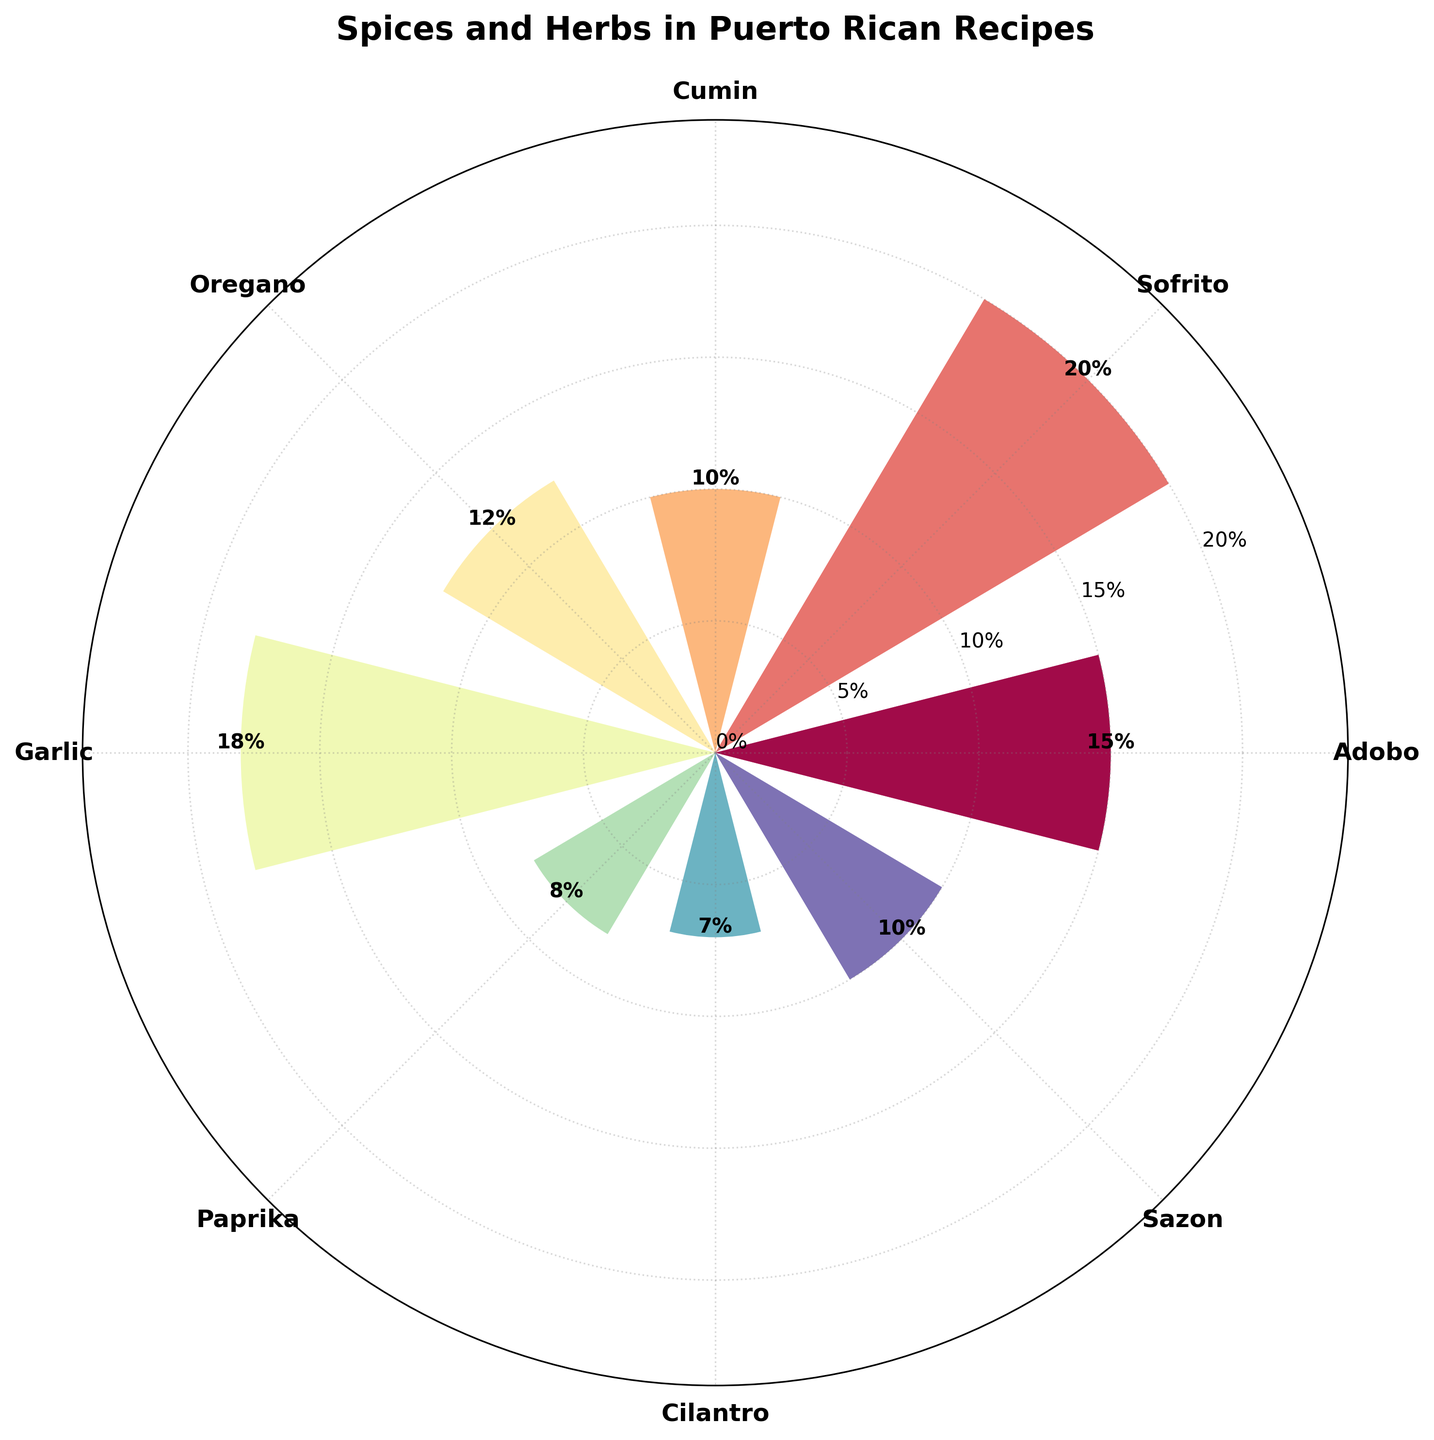What's the title of the figure? The title is typically located at the top of the figure. It describes the main topic or purpose of the chart.
Answer: Spices and Herbs in Puerto Rican Recipes Which spice/herb has the highest percentage of usage? By examining the heights of the bars, the tallest bar represents the spice/herb with the highest percentage.
Answer: Sofrito How many spices/herbs are shown in the chart? Count the number of different labeled bars or segments depicted around the polar axis.
Answer: 8 What is the combined usage percentage of Adobo and Sazon? Sum the percentage values associated with Adobo and Sazon from the chart. Adobo is 15%, and Sazon is 10%. Therefore, add 15% + 10%.
Answer: 25% Which spice/herb is used less, Cumin or Paprika? Compare the two heights of the bars corresponding to Cumin and Paprika. The shorter bar indicates the lesser-used herb.
Answer: Paprika What is the percentage difference between Garlic and Cilantro usage? Find the values for Garlic (18%) and Cilantro (7%), then subtract the smaller value from the larger one to find the difference.
Answer: 11% Is Oregano used more or less frequently than Cumin? Compare the heights of the corresponding bars for Oregano and Cumin. The taller bar indicates higher usage.
Answer: More Arrange the spices/herbs in decreasing order of usage based on the chart. List all the spices/herbs starting from the one with the highest bar to the one with the lowest, referring to the chart percentages.
Answer: Sofrito, Garlic, Adobo, Oregano, Cumin, Sazon, Paprika, Cilantro What is the average percentage usage of all the spices and herbs combined? To find the average, sum all the percentage values and then divide by the number of spices/herbs. (15%+20%+10%+12%+18%+8%+7%+10%) / 8
Answer: 12.5% In which section (segment) of the polar plot is Cilantro located? Is it in the top half or bottom half? Look at the orientation of Cilantro's bar on the polar plot. Determine if its theta angle places it above or below the horizontal axis.
Answer: Bottom half 